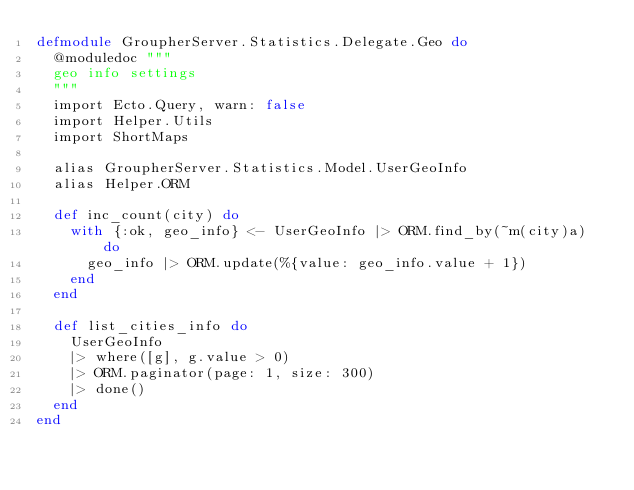<code> <loc_0><loc_0><loc_500><loc_500><_Elixir_>defmodule GroupherServer.Statistics.Delegate.Geo do
  @moduledoc """
  geo info settings
  """
  import Ecto.Query, warn: false
  import Helper.Utils
  import ShortMaps

  alias GroupherServer.Statistics.Model.UserGeoInfo
  alias Helper.ORM

  def inc_count(city) do
    with {:ok, geo_info} <- UserGeoInfo |> ORM.find_by(~m(city)a) do
      geo_info |> ORM.update(%{value: geo_info.value + 1})
    end
  end

  def list_cities_info do
    UserGeoInfo
    |> where([g], g.value > 0)
    |> ORM.paginator(page: 1, size: 300)
    |> done()
  end
end
</code> 